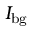<formula> <loc_0><loc_0><loc_500><loc_500>I _ { b g }</formula> 